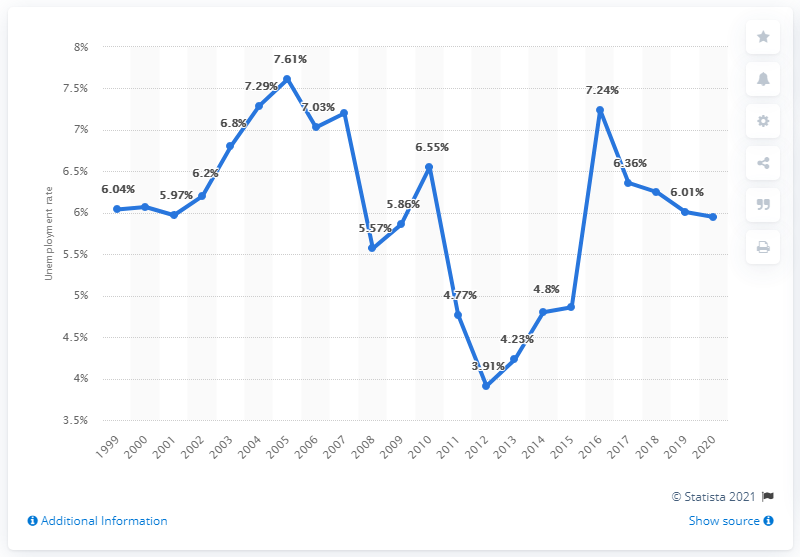Give some essential details in this illustration. In 2020, the unemployment rate in Mongolia was 5.95%. 